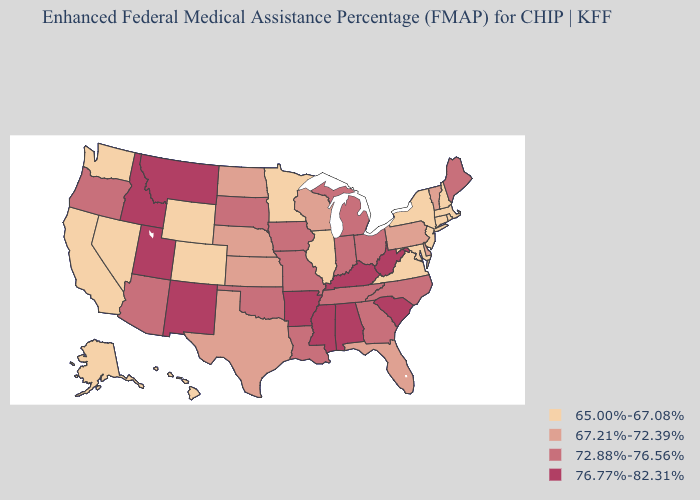Does the map have missing data?
Give a very brief answer. No. What is the lowest value in states that border Idaho?
Give a very brief answer. 65.00%-67.08%. Does Rhode Island have the lowest value in the USA?
Keep it brief. Yes. Name the states that have a value in the range 65.00%-67.08%?
Answer briefly. Alaska, California, Colorado, Connecticut, Hawaii, Illinois, Maryland, Massachusetts, Minnesota, Nevada, New Hampshire, New Jersey, New York, Rhode Island, Virginia, Washington, Wyoming. Name the states that have a value in the range 72.88%-76.56%?
Keep it brief. Arizona, Georgia, Indiana, Iowa, Louisiana, Maine, Michigan, Missouri, North Carolina, Ohio, Oklahoma, Oregon, South Dakota, Tennessee. Name the states that have a value in the range 65.00%-67.08%?
Give a very brief answer. Alaska, California, Colorado, Connecticut, Hawaii, Illinois, Maryland, Massachusetts, Minnesota, Nevada, New Hampshire, New Jersey, New York, Rhode Island, Virginia, Washington, Wyoming. Which states have the highest value in the USA?
Concise answer only. Alabama, Arkansas, Idaho, Kentucky, Mississippi, Montana, New Mexico, South Carolina, Utah, West Virginia. Which states have the highest value in the USA?
Give a very brief answer. Alabama, Arkansas, Idaho, Kentucky, Mississippi, Montana, New Mexico, South Carolina, Utah, West Virginia. Name the states that have a value in the range 65.00%-67.08%?
Write a very short answer. Alaska, California, Colorado, Connecticut, Hawaii, Illinois, Maryland, Massachusetts, Minnesota, Nevada, New Hampshire, New Jersey, New York, Rhode Island, Virginia, Washington, Wyoming. Does New York have a higher value than Tennessee?
Concise answer only. No. Does Nevada have a lower value than Texas?
Concise answer only. Yes. Name the states that have a value in the range 65.00%-67.08%?
Keep it brief. Alaska, California, Colorado, Connecticut, Hawaii, Illinois, Maryland, Massachusetts, Minnesota, Nevada, New Hampshire, New Jersey, New York, Rhode Island, Virginia, Washington, Wyoming. What is the lowest value in the South?
Keep it brief. 65.00%-67.08%. Does the first symbol in the legend represent the smallest category?
Give a very brief answer. Yes. Does Minnesota have the lowest value in the USA?
Be succinct. Yes. 